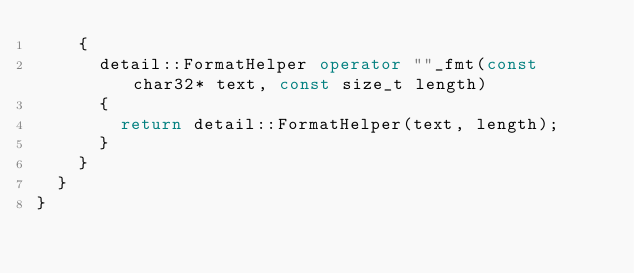<code> <loc_0><loc_0><loc_500><loc_500><_C++_>		{
			detail::FormatHelper operator ""_fmt(const char32* text, const size_t length)
			{
				return detail::FormatHelper(text, length);
			}
		}
	}
}
</code> 